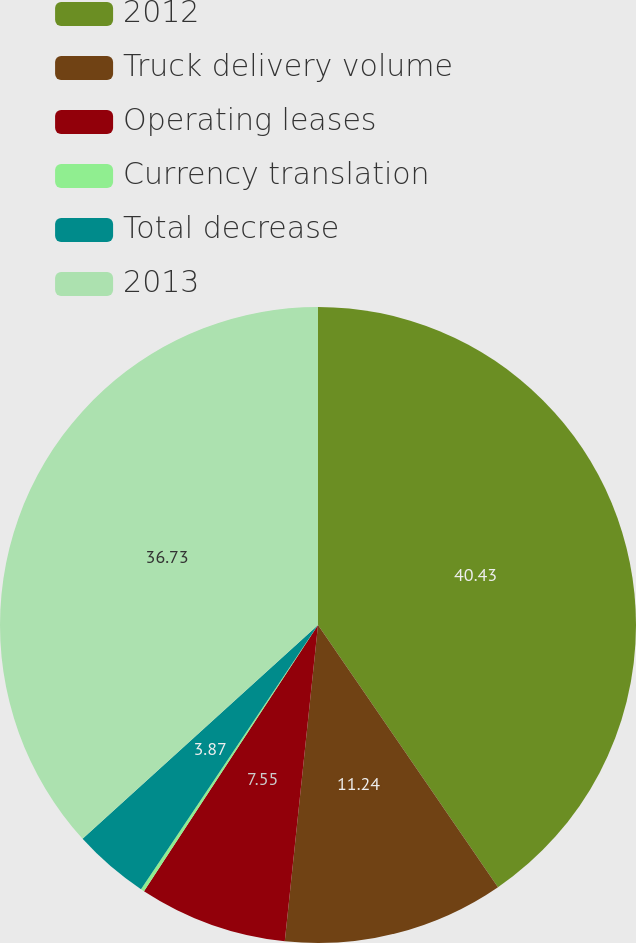Convert chart to OTSL. <chart><loc_0><loc_0><loc_500><loc_500><pie_chart><fcel>2012<fcel>Truck delivery volume<fcel>Operating leases<fcel>Currency translation<fcel>Total decrease<fcel>2013<nl><fcel>40.42%<fcel>11.24%<fcel>7.55%<fcel>0.18%<fcel>3.87%<fcel>36.73%<nl></chart> 